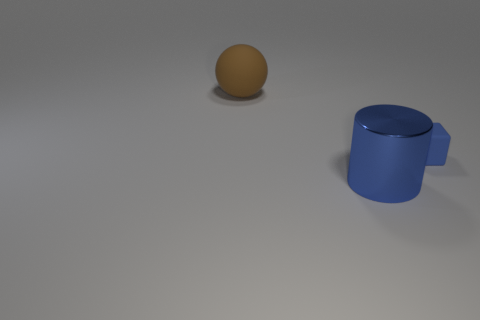Add 3 big gray metal cylinders. How many objects exist? 6 Subtract all balls. How many objects are left? 2 Add 2 large yellow rubber spheres. How many large yellow rubber spheres exist? 2 Subtract 0 red cylinders. How many objects are left? 3 Subtract all tiny cyan things. Subtract all blue shiny cylinders. How many objects are left? 2 Add 1 brown matte balls. How many brown matte balls are left? 2 